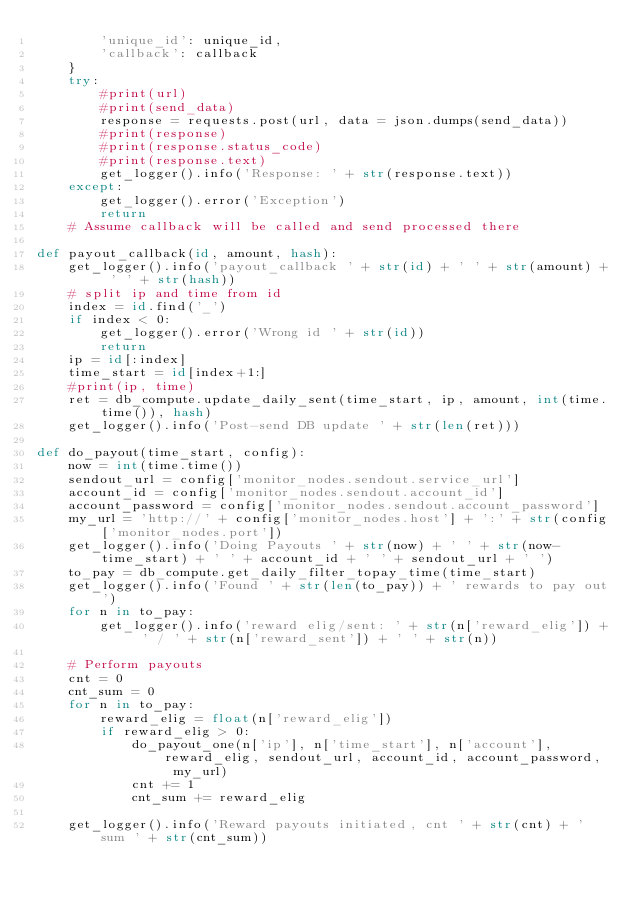Convert code to text. <code><loc_0><loc_0><loc_500><loc_500><_Python_>        'unique_id': unique_id,
        'callback': callback
    }
    try:
        #print(url)
        #print(send_data)
        response = requests.post(url, data = json.dumps(send_data))
        #print(response)
        #print(response.status_code)
        #print(response.text)
        get_logger().info('Response: ' + str(response.text))
    except:
        get_logger().error('Exception')
        return
    # Assume callback will be called and send processed there

def payout_callback(id, amount, hash):
    get_logger().info('payout_callback ' + str(id) + ' ' + str(amount) + ' ' + str(hash))
    # split ip and time from id
    index = id.find('_')
    if index < 0:
        get_logger().error('Wrong id ' + str(id))
        return
    ip = id[:index]
    time_start = id[index+1:]
    #print(ip, time)
    ret = db_compute.update_daily_sent(time_start, ip, amount, int(time.time()), hash)
    get_logger().info('Post-send DB update ' + str(len(ret)))

def do_payout(time_start, config):
    now = int(time.time())
    sendout_url = config['monitor_nodes.sendout.service_url']
    account_id = config['monitor_nodes.sendout.account_id']
    account_password = config['monitor_nodes.sendout.account_password']
    my_url = 'http://' + config['monitor_nodes.host'] + ':' + str(config['monitor_nodes.port'])
    get_logger().info('Doing Payouts ' + str(now) + ' ' + str(now-time_start) + ' ' + account_id + ' ' + sendout_url + ' ')
    to_pay = db_compute.get_daily_filter_topay_time(time_start)
    get_logger().info('Found ' + str(len(to_pay)) + ' rewards to pay out')
    for n in to_pay:
        get_logger().info('reward elig/sent: ' + str(n['reward_elig']) + ' / ' + str(n['reward_sent']) + ' ' + str(n))
    
    # Perform payouts
    cnt = 0
    cnt_sum = 0
    for n in to_pay:
        reward_elig = float(n['reward_elig'])
        if reward_elig > 0:
            do_payout_one(n['ip'], n['time_start'], n['account'], reward_elig, sendout_url, account_id, account_password, my_url)
            cnt += 1
            cnt_sum += reward_elig

    get_logger().info('Reward payouts initiated, cnt ' + str(cnt) + ' sum ' + str(cnt_sum))
</code> 